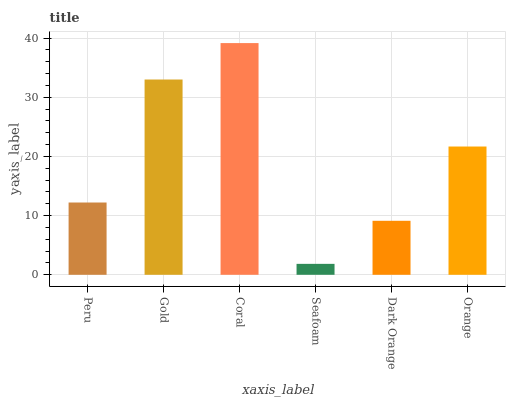Is Seafoam the minimum?
Answer yes or no. Yes. Is Coral the maximum?
Answer yes or no. Yes. Is Gold the minimum?
Answer yes or no. No. Is Gold the maximum?
Answer yes or no. No. Is Gold greater than Peru?
Answer yes or no. Yes. Is Peru less than Gold?
Answer yes or no. Yes. Is Peru greater than Gold?
Answer yes or no. No. Is Gold less than Peru?
Answer yes or no. No. Is Orange the high median?
Answer yes or no. Yes. Is Peru the low median?
Answer yes or no. Yes. Is Seafoam the high median?
Answer yes or no. No. Is Gold the low median?
Answer yes or no. No. 